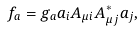<formula> <loc_0><loc_0><loc_500><loc_500>f _ { a } = g _ { a } a _ { i } A _ { \mu i } A _ { \mu j } ^ { * } a _ { j } ,</formula> 